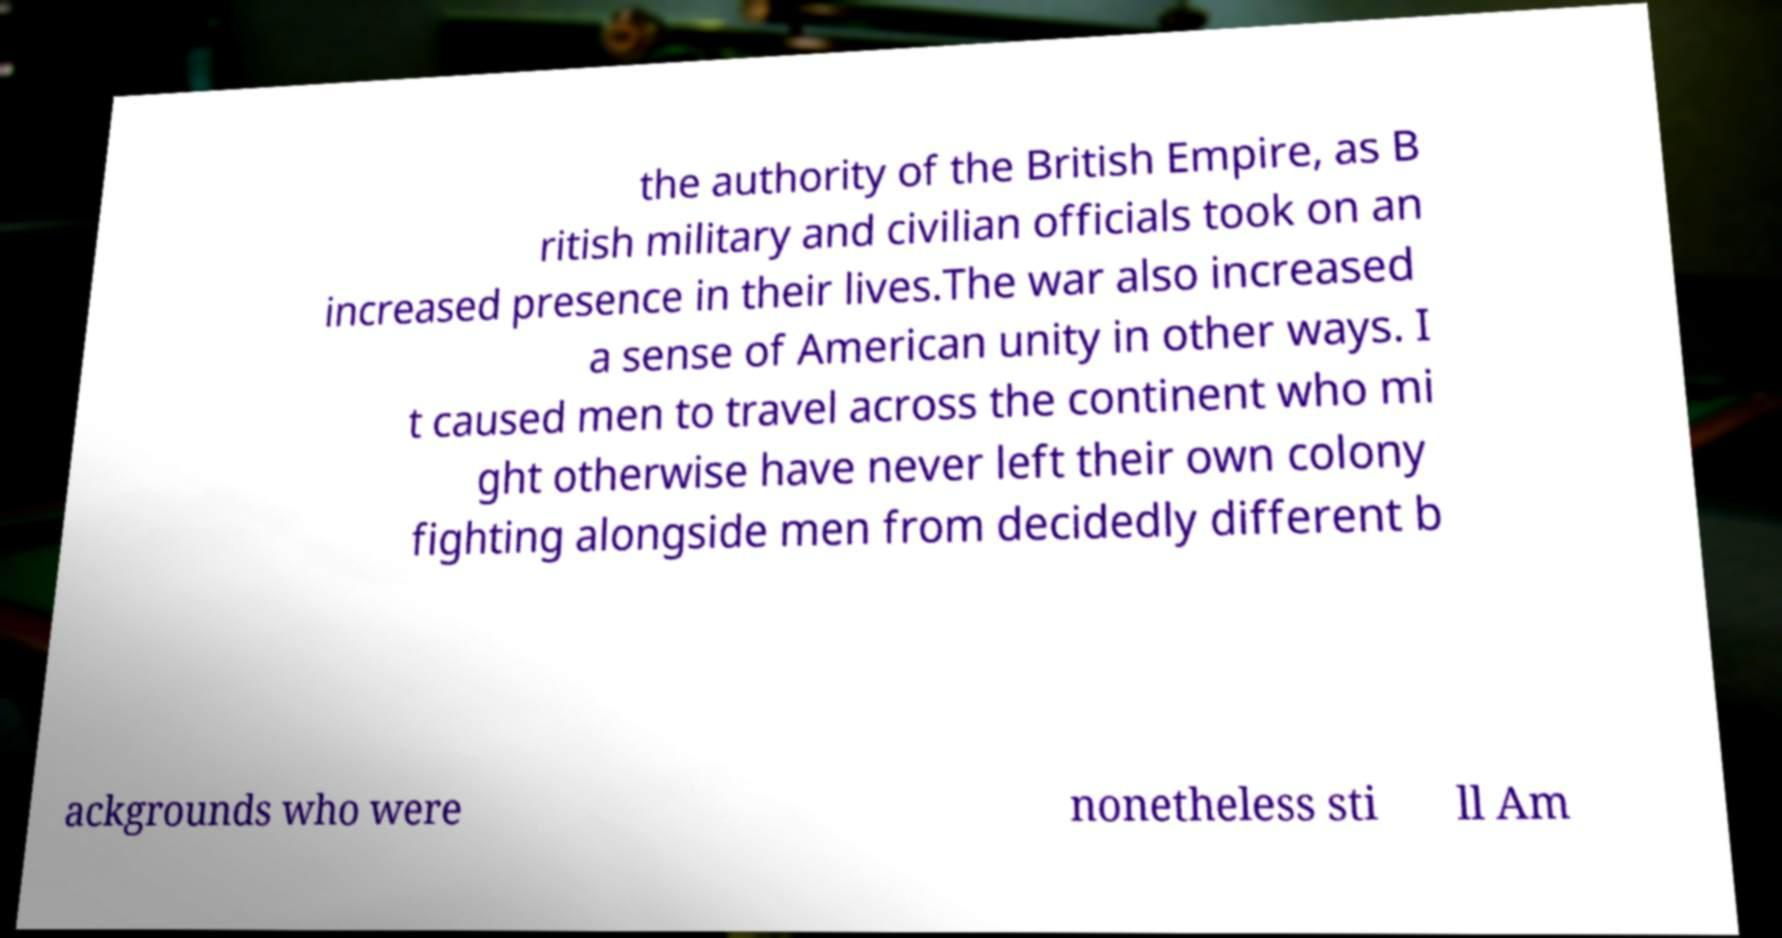Please read and relay the text visible in this image. What does it say? the authority of the British Empire, as B ritish military and civilian officials took on an increased presence in their lives.The war also increased a sense of American unity in other ways. I t caused men to travel across the continent who mi ght otherwise have never left their own colony fighting alongside men from decidedly different b ackgrounds who were nonetheless sti ll Am 